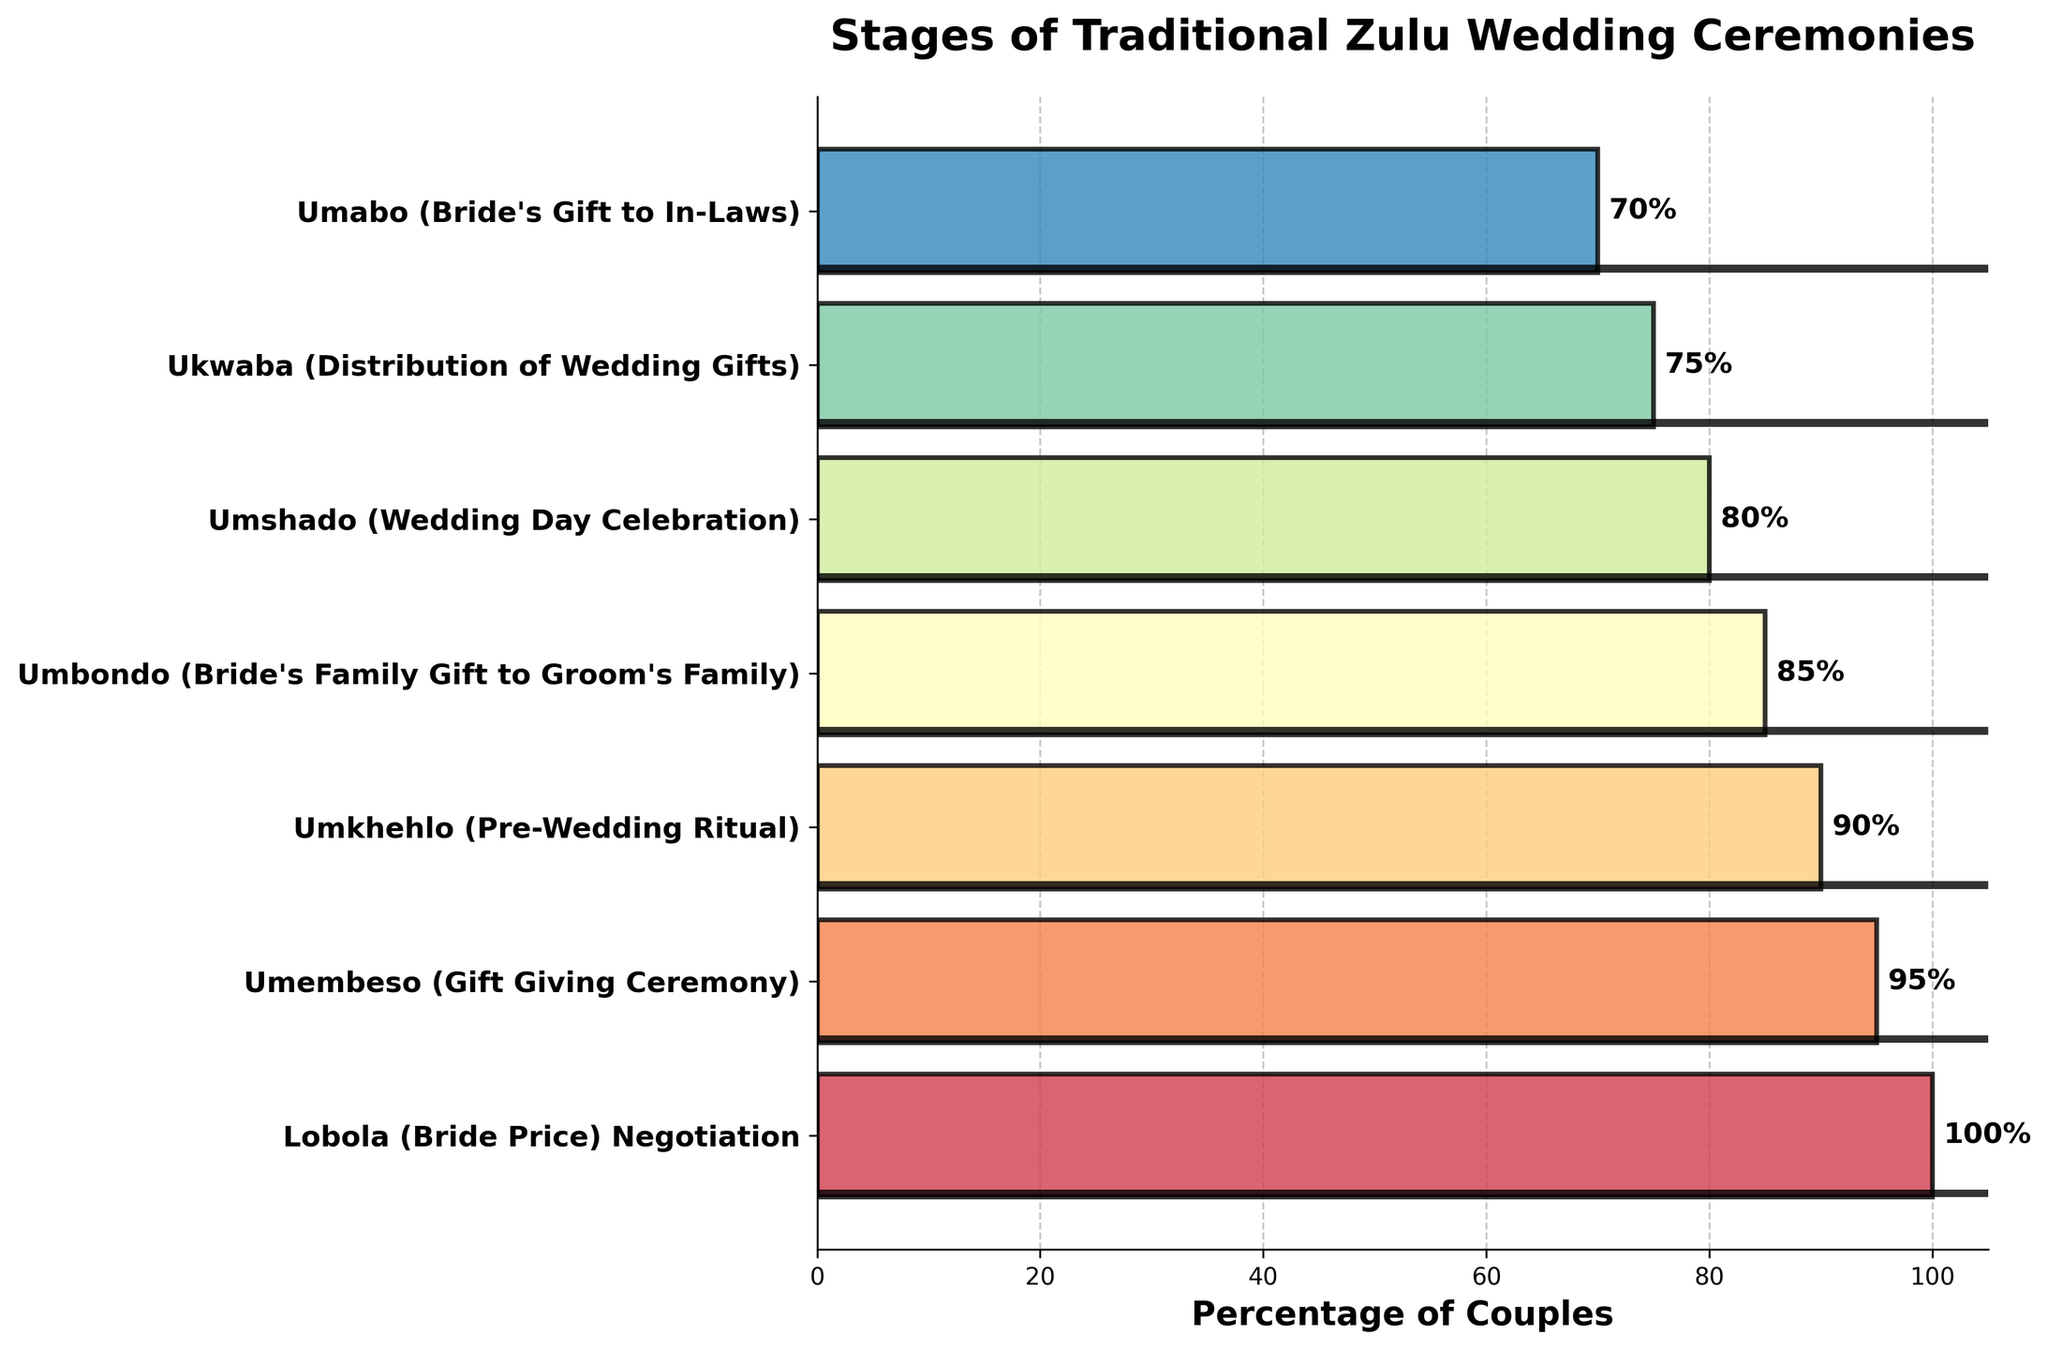What's the title of the figure? The title is centered at the top of the figure and describes the overall content.
Answer: Stages of Traditional Zulu Wedding Ceremonies What percentage of couples complete the Umkhehlo (Pre-Wedding Ritual) stage? Locate the Umkhehlo stage on the y-axis and read the corresponding percentage on the x-axis.
Answer: 90% What is the difference in percentage between couples who complete the Lobola (Bride Price) Negotiation and those who complete the Umabo (Bride's Gift to In-Laws)? First, find the percentages for Lobola (100%) and Umabo (70%), then subtract the Umabo percentage from the Lobola percentage.
Answer: 30% What is the median percentage of couples completing the stages? List the percentages in ascending order: 70%, 75%, 80%, 85%, 90%, 95%, 100%, and find the middle value (or the average of the two middle values, if the list length is even).
Answer: 85% Which stage has the lowest percentage of couples completing it? Look for the stage with the smallest bar length on the x-axis.
Answer: Umabo (Bride's Gift to In-Laws) How many stages are listed in the figure? Count the number of bars or labels along the y-axis.
Answer: 7 What is the combined percentage of couples completing the Umshado, Ukwaba, and Umabo stages? Add the percentages of Umshado (80%), Ukwaba (75%), and Umabo (70%).
Answer: 225% Is the percentage of couples completing the Umembeso (Gift Giving Ceremony) closer to the percentage for Umkhehlo (Pre-Wedding Ritual) or to Umshado (Wedding Day Celebration)? Compare the differences: from Umembeso (95%) to Umkhehlo (90%) is 5%, and from Umembeso to Umshado (80%) is 15%. Since 5% < 15%, it's closer to Umkhehlo.
Answer: Umkhehlo (Pre-Wedding Ritual) What is the average percentage of couples completing all stages? Sum up all the percentages and divide by the number of stages (7).
Answer: (100 + 95 + 90 + 85 + 80 + 75 + 70) / 7 = 85 Which two consecutive stages have the smallest difference in the percentage of couples completing them? Calculate the differences between consecutive stages and identify the smallest one: Lobola to Umembeso (5%), Umembeso to Umkhehlo (5%), Umkhehlo to Umbondo (5%), Umbondo to Umshado (5%), Umshado to Ukwaba (5%), Ukwaba to Umabo (5%). All differences are equal at 5%.
Answer: Lobola to Umembeso 